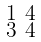<formula> <loc_0><loc_0><loc_500><loc_500>\begin{smallmatrix} 1 & 4 \\ 3 & 4 \end{smallmatrix}</formula> 